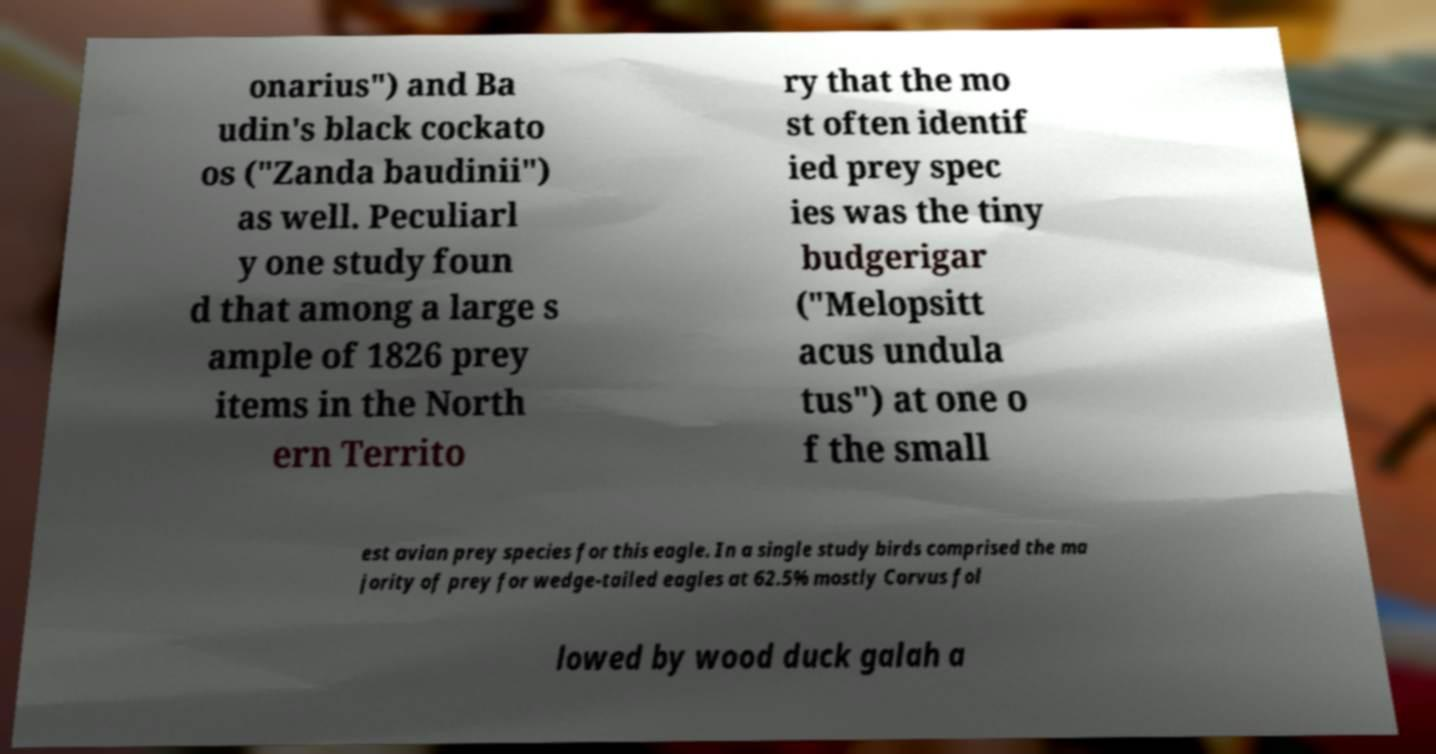Can you read and provide the text displayed in the image?This photo seems to have some interesting text. Can you extract and type it out for me? onarius") and Ba udin's black cockato os ("Zanda baudinii") as well. Peculiarl y one study foun d that among a large s ample of 1826 prey items in the North ern Territo ry that the mo st often identif ied prey spec ies was the tiny budgerigar ("Melopsitt acus undula tus") at one o f the small est avian prey species for this eagle. In a single study birds comprised the ma jority of prey for wedge-tailed eagles at 62.5% mostly Corvus fol lowed by wood duck galah a 